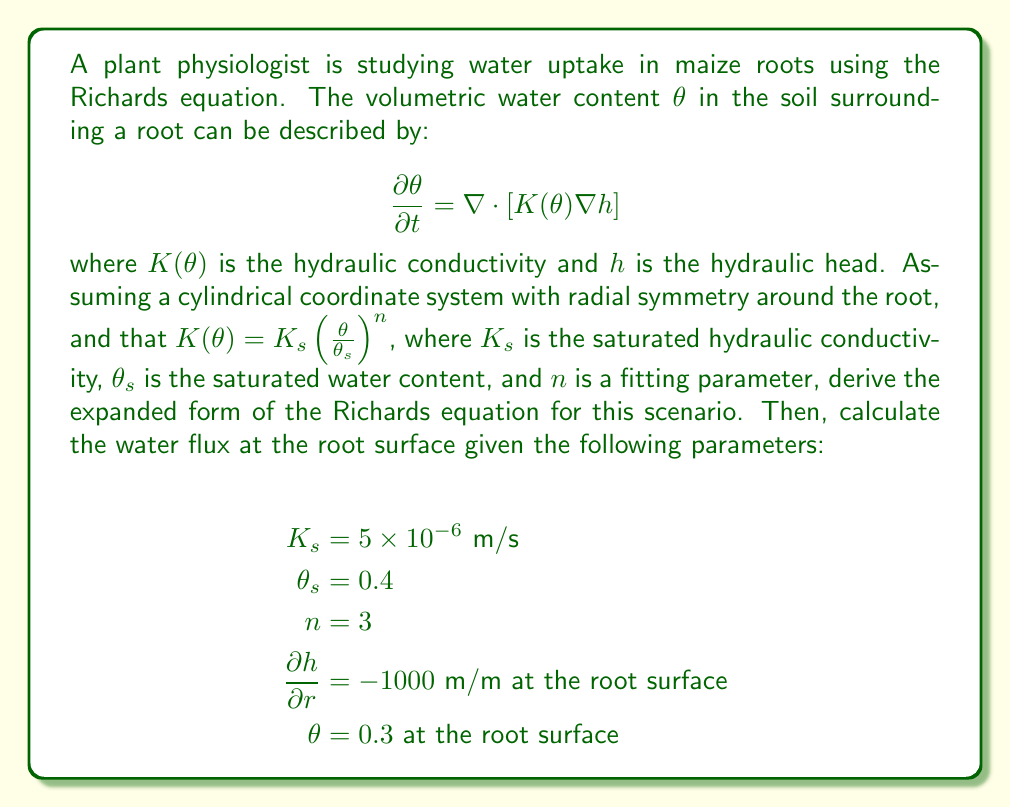Help me with this question. To solve this problem, we'll follow these steps:

1. Expand the Richards equation in cylindrical coordinates with radial symmetry.
2. Substitute the given hydraulic conductivity function.
3. Calculate the water flux at the root surface using the provided parameters.

Step 1: Expand the Richards equation in cylindrical coordinates

In cylindrical coordinates with radial symmetry, the nabla operator becomes:

$$\nabla \cdot [K(\theta) \nabla h] = \frac{1}{r} \frac{\partial}{\partial r}\left(r K(\theta) \frac{\partial h}{\partial r}\right)$$

So, the Richards equation becomes:

$$\frac{\partial \theta}{\partial t} = \frac{1}{r} \frac{\partial}{\partial r}\left(r K(\theta) \frac{\partial h}{\partial r}\right)$$

Step 2: Substitute the hydraulic conductivity function

Given $K(\theta) = K_s \left(\frac{\theta}{\theta_s}\right)^n$, we substitute this into the equation:

$$\frac{\partial \theta}{\partial t} = \frac{1}{r} \frac{\partial}{\partial r}\left(r K_s \left(\frac{\theta}{\theta_s}\right)^n \frac{\partial h}{\partial r}\right)$$

This is the expanded form of the Richards equation for the given scenario.

Step 3: Calculate the water flux at the root surface

The water flux $q$ is given by Darcy's law:

$$q = -K(\theta) \frac{\partial h}{\partial r}$$

At the root surface, we have:
$\theta = 0.3$
$\frac{\partial h}{\partial r} = -1000$ m/m

First, calculate $K(\theta)$:

$$K(\theta) = K_s \left(\frac{\theta}{\theta_s}\right)^n = 5 \times 10^{-6} \left(\frac{0.3}{0.4}\right)^3 = 2.109375 \times 10^{-6}$$ m/s

Now, calculate the flux:

$$q = -K(\theta) \frac{\partial h}{\partial r} = -(2.109375 \times 10^{-6}) \times (-1000) = 2.109375 \times 10^{-3}$$ m/s
Answer: The expanded form of the Richards equation for this scenario is:

$$\frac{\partial \theta}{\partial t} = \frac{1}{r} \frac{\partial}{\partial r}\left(r K_s \left(\frac{\theta}{\theta_s}\right)^n \frac{\partial h}{\partial r}\right)$$

The water flux at the root surface is $2.109375 \times 10^{-3}$ m/s. 